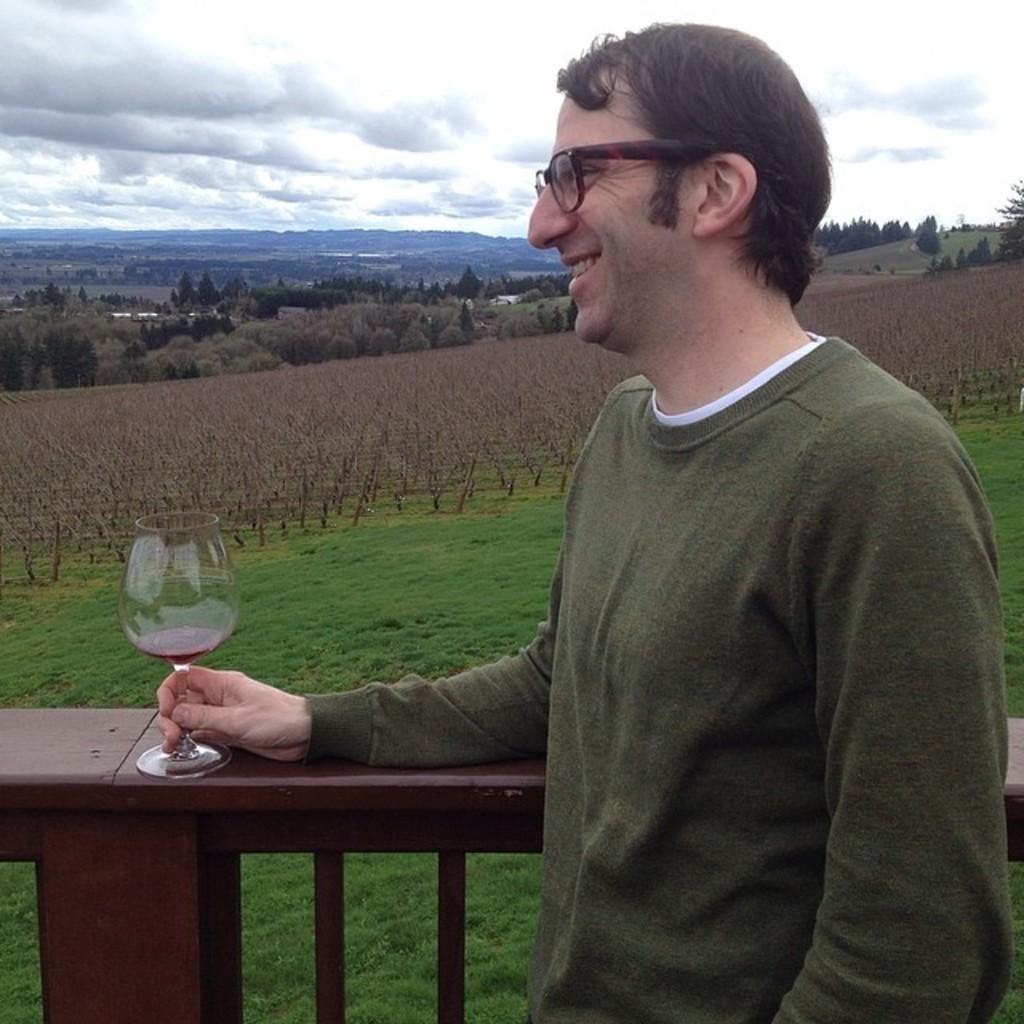In one or two sentences, can you explain what this image depicts? In the image there is a man in green t-shirt holding a wine glass in front of wooden fence and in the back there are many plants and trees all over the place on the grassland and above its sky with clouds. 